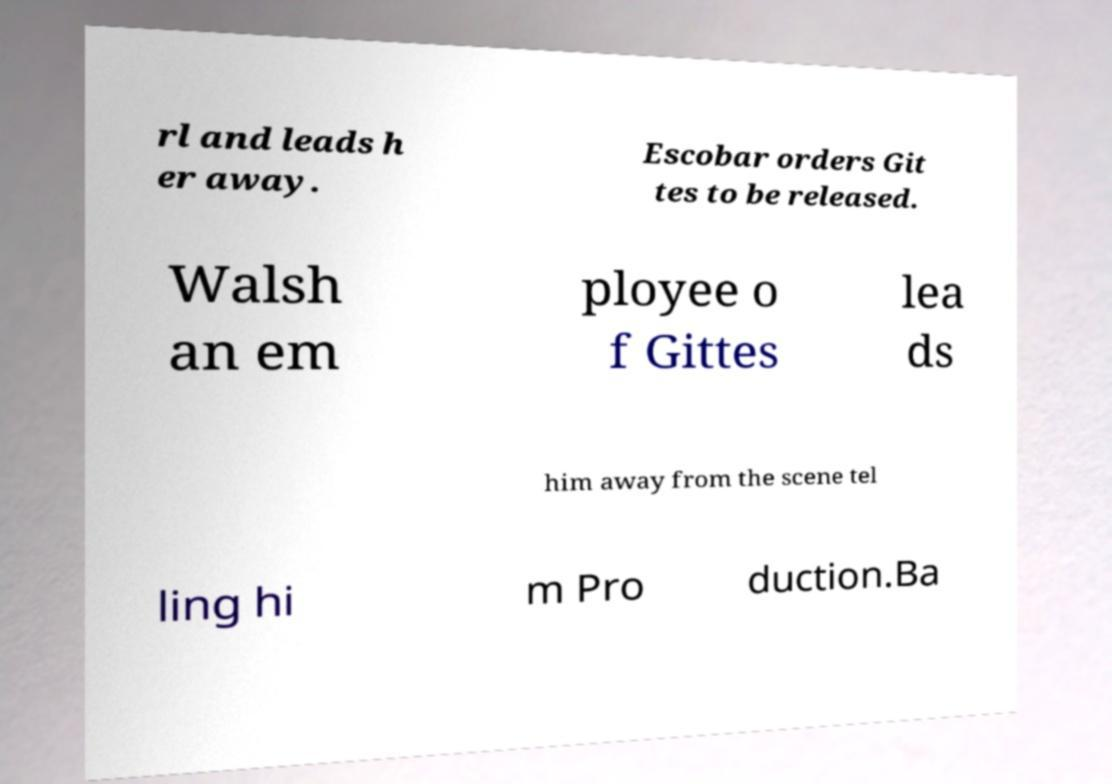For documentation purposes, I need the text within this image transcribed. Could you provide that? rl and leads h er away. Escobar orders Git tes to be released. Walsh an em ployee o f Gittes lea ds him away from the scene tel ling hi m Pro duction.Ba 